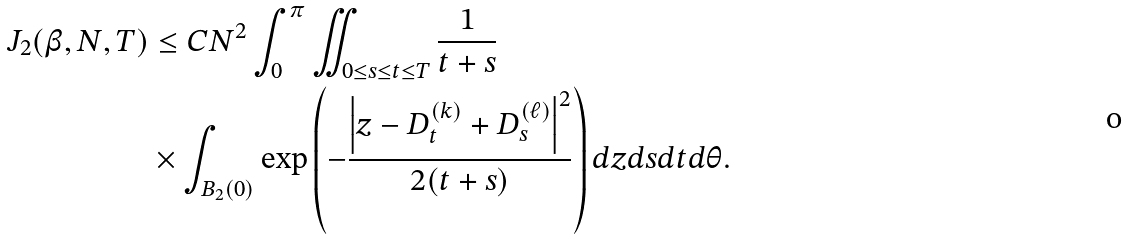Convert formula to latex. <formula><loc_0><loc_0><loc_500><loc_500>J _ { 2 } ( \beta , N , T ) & \leq C N ^ { 2 } \int _ { 0 } ^ { \pi } \iint _ { 0 \leq s \leq t \leq T } \frac { 1 } { t + s } \\ & \times \int _ { B _ { 2 } ( 0 ) } \exp \left ( - \frac { \left | z - D _ { t } ^ { ( k ) } + D _ { s } ^ { ( \ell ) } \right | ^ { 2 } } { 2 ( t + s ) } \right ) d z d s d t d \theta .</formula> 